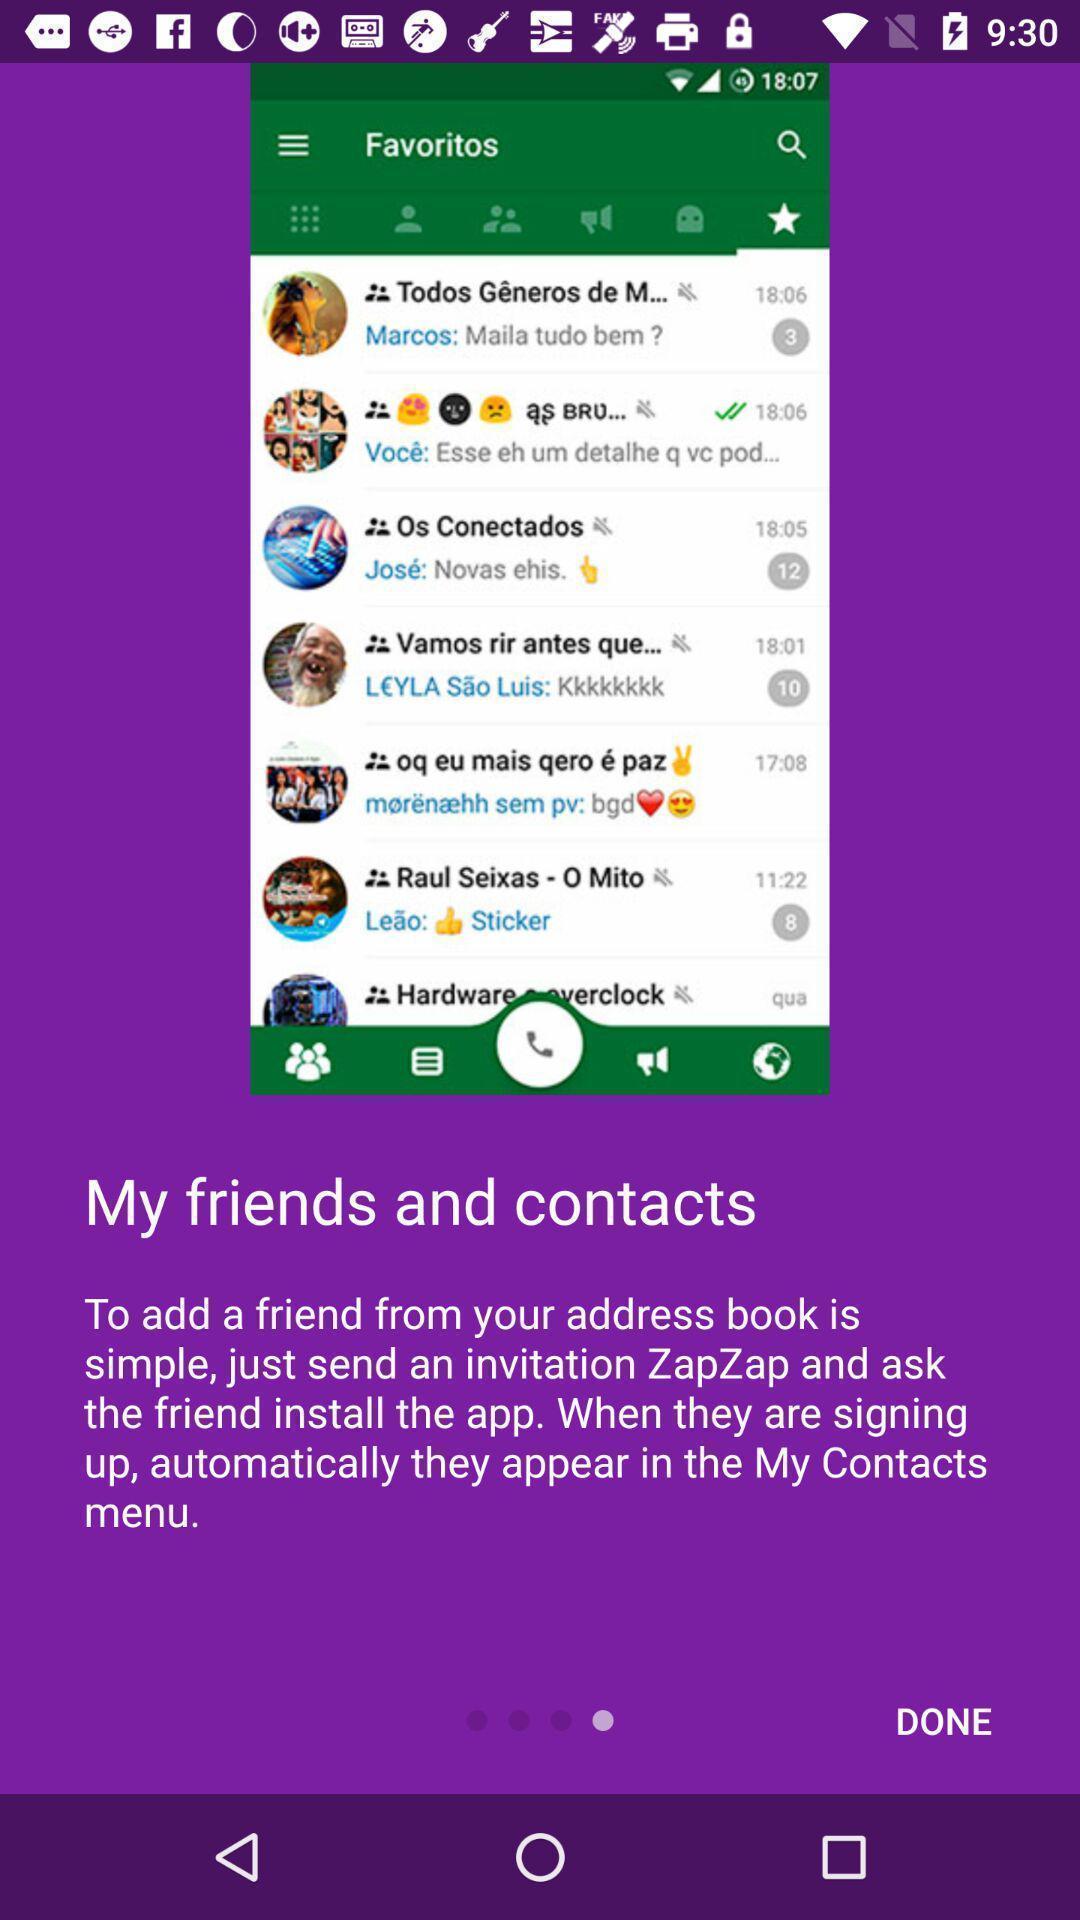Summarize the information in this screenshot. Welcome page for a social application for messaging. 